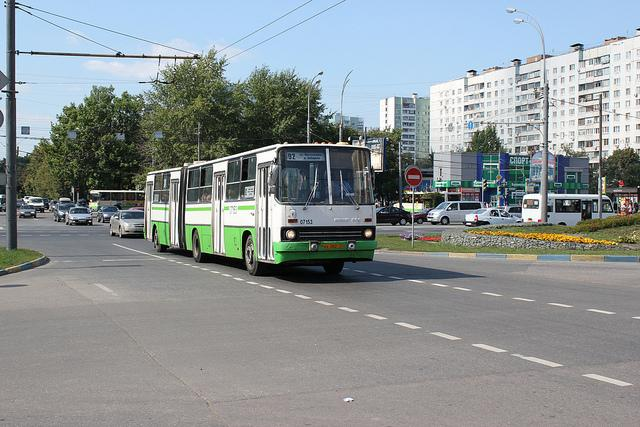What type setting is this roadway located in? city 